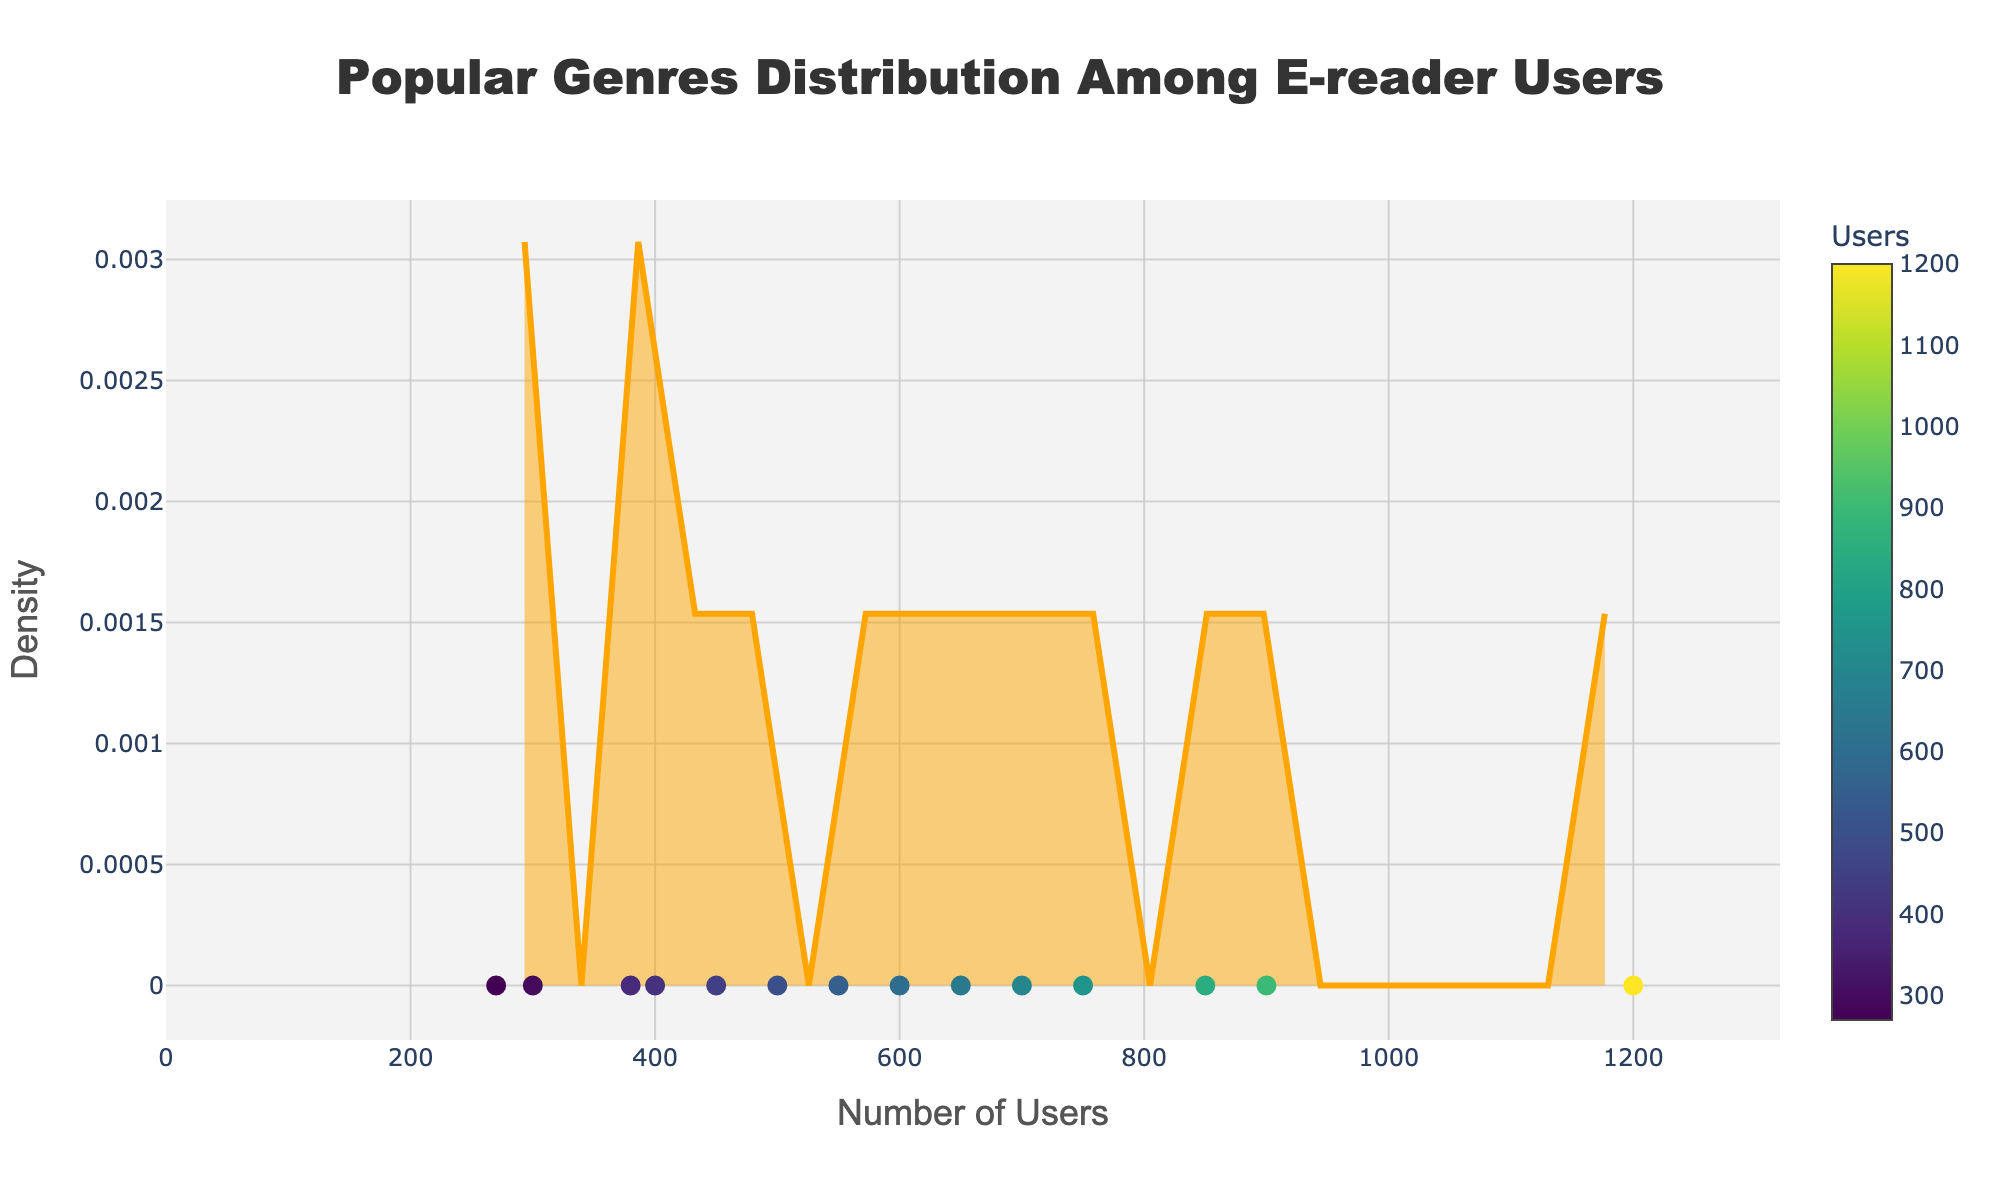What genre has the highest number of users? By looking at the scatter plot below the density curve, identify the data point with the highest x-axis value and check its corresponding genre provided in the hover info.
Answer: Fiction How many genres have more than 700 users? Count the data points to the right of the x-axis value 700 in the scatter plot.
Answer: Six What is the title of the figure? Look at the text displayed at the top of the figure.
Answer: Popular Genres Distribution Among E-reader Users Which genre has the fewest users? Find the data point with the lowest x-axis value in the scatter plot and check its corresponding genre provided in the hover info.
Answer: Poetry Are there more users interested in Non-Fiction or Fantasy? Compare the x-axis values of the data points representing Non-Fiction and Fantasy in the scatter plot. Non-Fiction has 900 users, while Fantasy has 850 users.
Answer: Non-Fiction How many genres have 500 or fewer users? Count the data points to the left of or exactly at the x-axis value 500 in the scatter plot.
Answer: Five What is the total number of users for Mystery, Science Fiction, and Romance? Add the number of users for these genres: 700 (Mystery) + 600 (Science Fiction) + 650 (Romance) = 1950.
Answer: 1950 Which genre's user count is closest to the average number of users? First, calculate the average number of users by summing all user counts and dividing by the number of genres. Then, determine which genre has a user count closest to this average. Average = (1200 + 900 + 700 + 600 + 850 + 500 + 750 + 650 + 400 + 550 + 300 + 450 + 380 + 270) / 14 = 642.14. Romance, with 650 users, is the closest.
Answer: Romance 